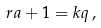Convert formula to latex. <formula><loc_0><loc_0><loc_500><loc_500>r a + 1 = k q \, ,</formula> 